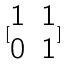<formula> <loc_0><loc_0><loc_500><loc_500>[ \begin{matrix} 1 & 1 \\ 0 & 1 \end{matrix} ]</formula> 